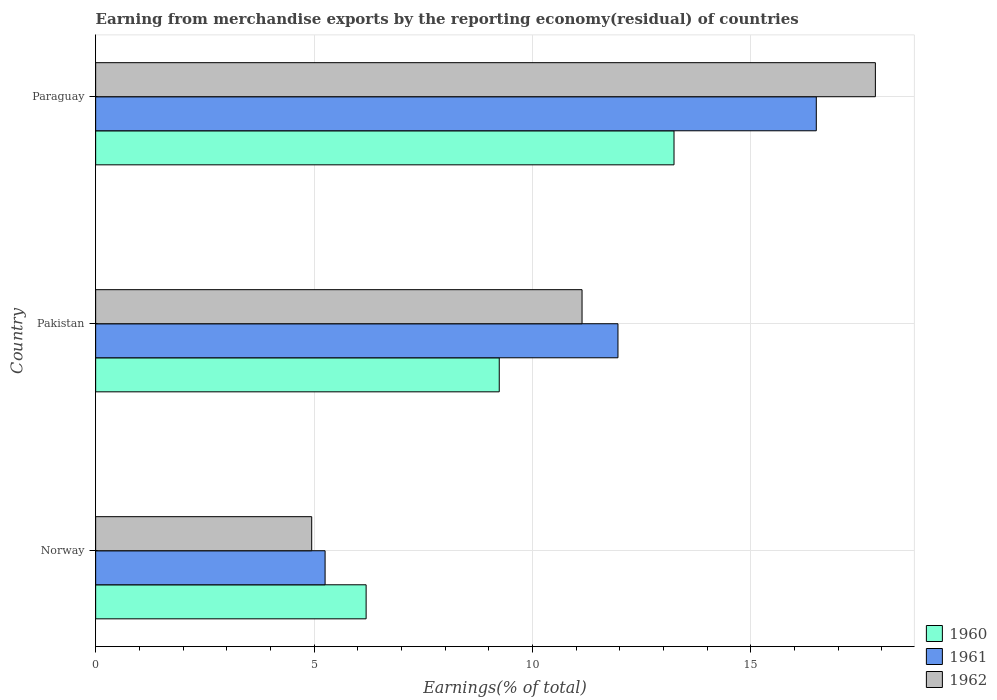How many groups of bars are there?
Ensure brevity in your answer.  3. Are the number of bars on each tick of the Y-axis equal?
Provide a short and direct response. Yes. What is the percentage of amount earned from merchandise exports in 1961 in Norway?
Ensure brevity in your answer.  5.25. Across all countries, what is the maximum percentage of amount earned from merchandise exports in 1961?
Give a very brief answer. 16.5. Across all countries, what is the minimum percentage of amount earned from merchandise exports in 1962?
Offer a very short reply. 4.95. In which country was the percentage of amount earned from merchandise exports in 1962 maximum?
Your answer should be compact. Paraguay. What is the total percentage of amount earned from merchandise exports in 1961 in the graph?
Provide a succinct answer. 33.71. What is the difference between the percentage of amount earned from merchandise exports in 1961 in Pakistan and that in Paraguay?
Your answer should be very brief. -4.54. What is the difference between the percentage of amount earned from merchandise exports in 1962 in Pakistan and the percentage of amount earned from merchandise exports in 1960 in Paraguay?
Give a very brief answer. -2.11. What is the average percentage of amount earned from merchandise exports in 1960 per country?
Give a very brief answer. 9.56. What is the difference between the percentage of amount earned from merchandise exports in 1961 and percentage of amount earned from merchandise exports in 1962 in Paraguay?
Your answer should be compact. -1.35. What is the ratio of the percentage of amount earned from merchandise exports in 1960 in Norway to that in Paraguay?
Offer a terse response. 0.47. What is the difference between the highest and the second highest percentage of amount earned from merchandise exports in 1960?
Your answer should be very brief. 4. What is the difference between the highest and the lowest percentage of amount earned from merchandise exports in 1961?
Your response must be concise. 11.25. What does the 2nd bar from the top in Norway represents?
Your response must be concise. 1961. What does the 2nd bar from the bottom in Norway represents?
Offer a terse response. 1961. Is it the case that in every country, the sum of the percentage of amount earned from merchandise exports in 1962 and percentage of amount earned from merchandise exports in 1961 is greater than the percentage of amount earned from merchandise exports in 1960?
Provide a succinct answer. Yes. How many countries are there in the graph?
Your answer should be compact. 3. Are the values on the major ticks of X-axis written in scientific E-notation?
Ensure brevity in your answer.  No. Does the graph contain any zero values?
Your answer should be compact. No. Does the graph contain grids?
Your answer should be compact. Yes. Where does the legend appear in the graph?
Your answer should be very brief. Bottom right. How many legend labels are there?
Your response must be concise. 3. What is the title of the graph?
Your answer should be compact. Earning from merchandise exports by the reporting economy(residual) of countries. What is the label or title of the X-axis?
Provide a short and direct response. Earnings(% of total). What is the Earnings(% of total) in 1960 in Norway?
Make the answer very short. 6.19. What is the Earnings(% of total) of 1961 in Norway?
Keep it short and to the point. 5.25. What is the Earnings(% of total) in 1962 in Norway?
Offer a terse response. 4.95. What is the Earnings(% of total) of 1960 in Pakistan?
Offer a very short reply. 9.24. What is the Earnings(% of total) of 1961 in Pakistan?
Provide a short and direct response. 11.96. What is the Earnings(% of total) of 1962 in Pakistan?
Give a very brief answer. 11.14. What is the Earnings(% of total) of 1960 in Paraguay?
Your answer should be compact. 13.24. What is the Earnings(% of total) of 1961 in Paraguay?
Keep it short and to the point. 16.5. What is the Earnings(% of total) in 1962 in Paraguay?
Give a very brief answer. 17.85. Across all countries, what is the maximum Earnings(% of total) of 1960?
Provide a succinct answer. 13.24. Across all countries, what is the maximum Earnings(% of total) in 1961?
Offer a terse response. 16.5. Across all countries, what is the maximum Earnings(% of total) in 1962?
Your answer should be compact. 17.85. Across all countries, what is the minimum Earnings(% of total) of 1960?
Your response must be concise. 6.19. Across all countries, what is the minimum Earnings(% of total) in 1961?
Your response must be concise. 5.25. Across all countries, what is the minimum Earnings(% of total) of 1962?
Provide a short and direct response. 4.95. What is the total Earnings(% of total) of 1960 in the graph?
Provide a succinct answer. 28.67. What is the total Earnings(% of total) in 1961 in the graph?
Provide a short and direct response. 33.71. What is the total Earnings(% of total) in 1962 in the graph?
Offer a very short reply. 33.93. What is the difference between the Earnings(% of total) in 1960 in Norway and that in Pakistan?
Ensure brevity in your answer.  -3.05. What is the difference between the Earnings(% of total) in 1961 in Norway and that in Pakistan?
Make the answer very short. -6.71. What is the difference between the Earnings(% of total) in 1962 in Norway and that in Pakistan?
Offer a very short reply. -6.19. What is the difference between the Earnings(% of total) in 1960 in Norway and that in Paraguay?
Give a very brief answer. -7.05. What is the difference between the Earnings(% of total) of 1961 in Norway and that in Paraguay?
Your answer should be compact. -11.25. What is the difference between the Earnings(% of total) of 1962 in Norway and that in Paraguay?
Provide a succinct answer. -12.9. What is the difference between the Earnings(% of total) in 1960 in Pakistan and that in Paraguay?
Offer a very short reply. -4. What is the difference between the Earnings(% of total) in 1961 in Pakistan and that in Paraguay?
Provide a succinct answer. -4.54. What is the difference between the Earnings(% of total) of 1962 in Pakistan and that in Paraguay?
Your response must be concise. -6.72. What is the difference between the Earnings(% of total) of 1960 in Norway and the Earnings(% of total) of 1961 in Pakistan?
Give a very brief answer. -5.77. What is the difference between the Earnings(% of total) of 1960 in Norway and the Earnings(% of total) of 1962 in Pakistan?
Offer a terse response. -4.94. What is the difference between the Earnings(% of total) of 1961 in Norway and the Earnings(% of total) of 1962 in Pakistan?
Ensure brevity in your answer.  -5.88. What is the difference between the Earnings(% of total) of 1960 in Norway and the Earnings(% of total) of 1961 in Paraguay?
Your answer should be very brief. -10.31. What is the difference between the Earnings(% of total) in 1960 in Norway and the Earnings(% of total) in 1962 in Paraguay?
Give a very brief answer. -11.66. What is the difference between the Earnings(% of total) of 1961 in Norway and the Earnings(% of total) of 1962 in Paraguay?
Keep it short and to the point. -12.6. What is the difference between the Earnings(% of total) of 1960 in Pakistan and the Earnings(% of total) of 1961 in Paraguay?
Your response must be concise. -7.26. What is the difference between the Earnings(% of total) in 1960 in Pakistan and the Earnings(% of total) in 1962 in Paraguay?
Offer a terse response. -8.61. What is the difference between the Earnings(% of total) in 1961 in Pakistan and the Earnings(% of total) in 1962 in Paraguay?
Provide a succinct answer. -5.89. What is the average Earnings(% of total) in 1960 per country?
Your answer should be compact. 9.56. What is the average Earnings(% of total) of 1961 per country?
Your response must be concise. 11.24. What is the average Earnings(% of total) of 1962 per country?
Give a very brief answer. 11.31. What is the difference between the Earnings(% of total) in 1960 and Earnings(% of total) in 1961 in Norway?
Offer a terse response. 0.94. What is the difference between the Earnings(% of total) of 1960 and Earnings(% of total) of 1962 in Norway?
Your answer should be compact. 1.25. What is the difference between the Earnings(% of total) of 1961 and Earnings(% of total) of 1962 in Norway?
Ensure brevity in your answer.  0.31. What is the difference between the Earnings(% of total) in 1960 and Earnings(% of total) in 1961 in Pakistan?
Offer a terse response. -2.72. What is the difference between the Earnings(% of total) of 1960 and Earnings(% of total) of 1962 in Pakistan?
Provide a succinct answer. -1.9. What is the difference between the Earnings(% of total) in 1961 and Earnings(% of total) in 1962 in Pakistan?
Offer a terse response. 0.82. What is the difference between the Earnings(% of total) of 1960 and Earnings(% of total) of 1961 in Paraguay?
Provide a succinct answer. -3.26. What is the difference between the Earnings(% of total) of 1960 and Earnings(% of total) of 1962 in Paraguay?
Your response must be concise. -4.61. What is the difference between the Earnings(% of total) in 1961 and Earnings(% of total) in 1962 in Paraguay?
Your answer should be compact. -1.35. What is the ratio of the Earnings(% of total) in 1960 in Norway to that in Pakistan?
Provide a short and direct response. 0.67. What is the ratio of the Earnings(% of total) of 1961 in Norway to that in Pakistan?
Your answer should be very brief. 0.44. What is the ratio of the Earnings(% of total) of 1962 in Norway to that in Pakistan?
Ensure brevity in your answer.  0.44. What is the ratio of the Earnings(% of total) in 1960 in Norway to that in Paraguay?
Give a very brief answer. 0.47. What is the ratio of the Earnings(% of total) of 1961 in Norway to that in Paraguay?
Your answer should be very brief. 0.32. What is the ratio of the Earnings(% of total) in 1962 in Norway to that in Paraguay?
Your answer should be compact. 0.28. What is the ratio of the Earnings(% of total) in 1960 in Pakistan to that in Paraguay?
Provide a succinct answer. 0.7. What is the ratio of the Earnings(% of total) in 1961 in Pakistan to that in Paraguay?
Your answer should be compact. 0.72. What is the ratio of the Earnings(% of total) of 1962 in Pakistan to that in Paraguay?
Your answer should be compact. 0.62. What is the difference between the highest and the second highest Earnings(% of total) of 1960?
Provide a succinct answer. 4. What is the difference between the highest and the second highest Earnings(% of total) in 1961?
Provide a short and direct response. 4.54. What is the difference between the highest and the second highest Earnings(% of total) of 1962?
Provide a succinct answer. 6.72. What is the difference between the highest and the lowest Earnings(% of total) in 1960?
Keep it short and to the point. 7.05. What is the difference between the highest and the lowest Earnings(% of total) in 1961?
Keep it short and to the point. 11.25. What is the difference between the highest and the lowest Earnings(% of total) in 1962?
Your answer should be compact. 12.9. 